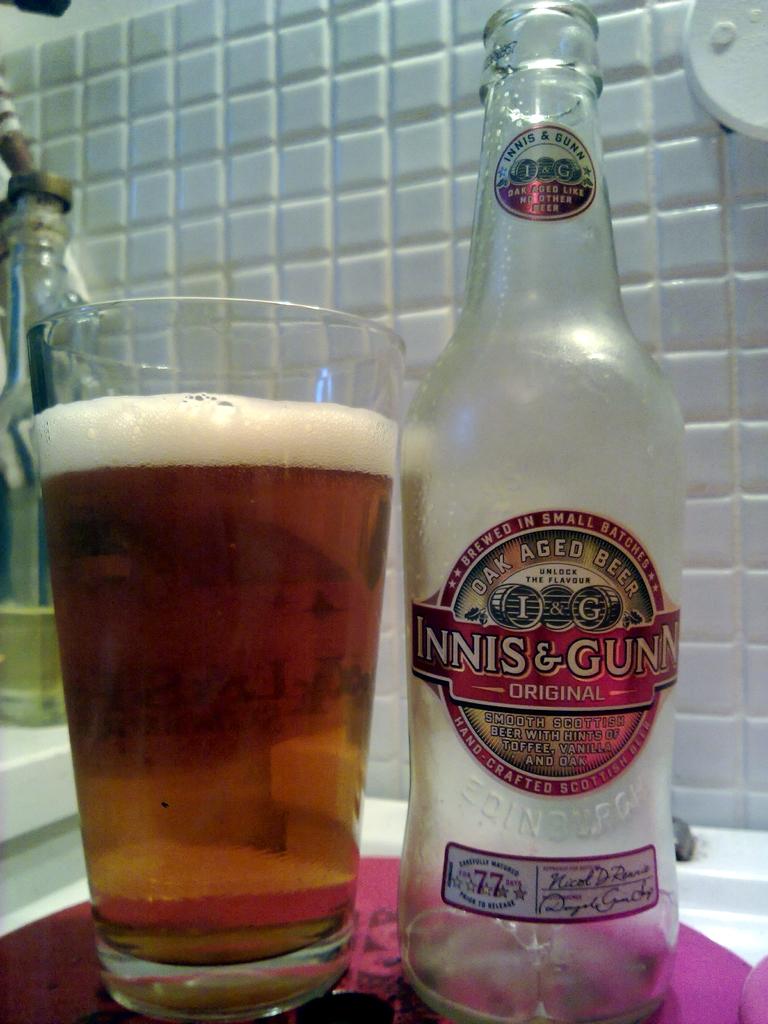What was the beer aged with?
Provide a short and direct response. Oak. 